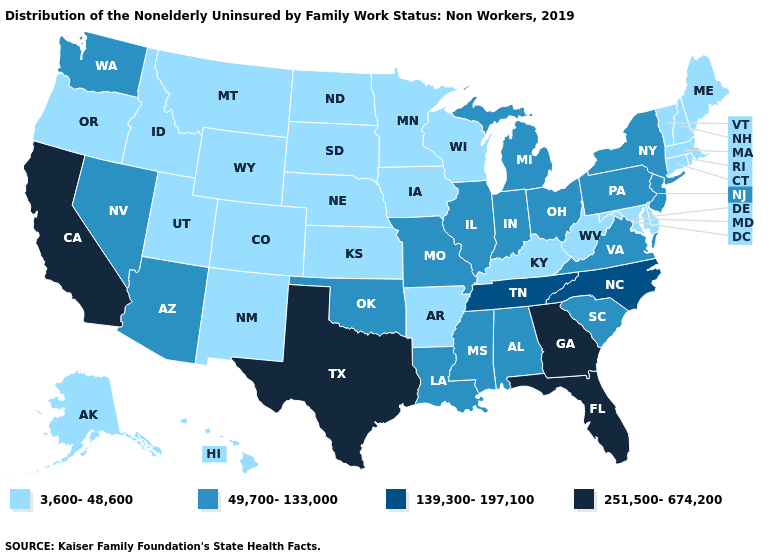Among the states that border Georgia , does North Carolina have the highest value?
Quick response, please. No. What is the value of New Jersey?
Be succinct. 49,700-133,000. Name the states that have a value in the range 251,500-674,200?
Keep it brief. California, Florida, Georgia, Texas. Among the states that border South Carolina , which have the highest value?
Write a very short answer. Georgia. Does Mississippi have a lower value than North Carolina?
Give a very brief answer. Yes. Which states have the lowest value in the USA?
Answer briefly. Alaska, Arkansas, Colorado, Connecticut, Delaware, Hawaii, Idaho, Iowa, Kansas, Kentucky, Maine, Maryland, Massachusetts, Minnesota, Montana, Nebraska, New Hampshire, New Mexico, North Dakota, Oregon, Rhode Island, South Dakota, Utah, Vermont, West Virginia, Wisconsin, Wyoming. Does Massachusetts have a lower value than Pennsylvania?
Write a very short answer. Yes. Among the states that border Oklahoma , which have the highest value?
Be succinct. Texas. What is the value of Tennessee?
Give a very brief answer. 139,300-197,100. Name the states that have a value in the range 49,700-133,000?
Write a very short answer. Alabama, Arizona, Illinois, Indiana, Louisiana, Michigan, Mississippi, Missouri, Nevada, New Jersey, New York, Ohio, Oklahoma, Pennsylvania, South Carolina, Virginia, Washington. What is the value of Utah?
Quick response, please. 3,600-48,600. Which states hav the highest value in the West?
Write a very short answer. California. What is the highest value in the USA?
Keep it brief. 251,500-674,200. What is the lowest value in states that border Minnesota?
Keep it brief. 3,600-48,600. Does Michigan have the lowest value in the MidWest?
Be succinct. No. 